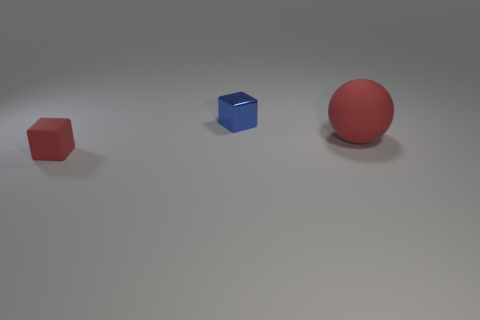How many other objects are the same color as the small metal cube?
Your response must be concise. 0. Is the number of matte objects that are to the right of the tiny red matte object less than the number of objects left of the large red matte thing?
Provide a succinct answer. Yes. What number of red things are there?
Offer a very short reply. 2. Is there any other thing that is made of the same material as the small blue cube?
Give a very brief answer. No. What is the material of the other tiny red object that is the same shape as the tiny metal object?
Make the answer very short. Rubber. Is the number of red cubes that are left of the big red rubber sphere less than the number of red things?
Give a very brief answer. Yes. There is a red thing to the left of the metallic object; does it have the same shape as the metallic object?
Offer a very short reply. Yes. Is there any other thing that is the same color as the metal block?
Your answer should be very brief. No. There is a red thing that is the same material as the large ball; what size is it?
Offer a terse response. Small. What is the object behind the red rubber object behind the red rubber object left of the red ball made of?
Keep it short and to the point. Metal. 